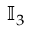<formula> <loc_0><loc_0><loc_500><loc_500>\mathbb { I } _ { 3 }</formula> 